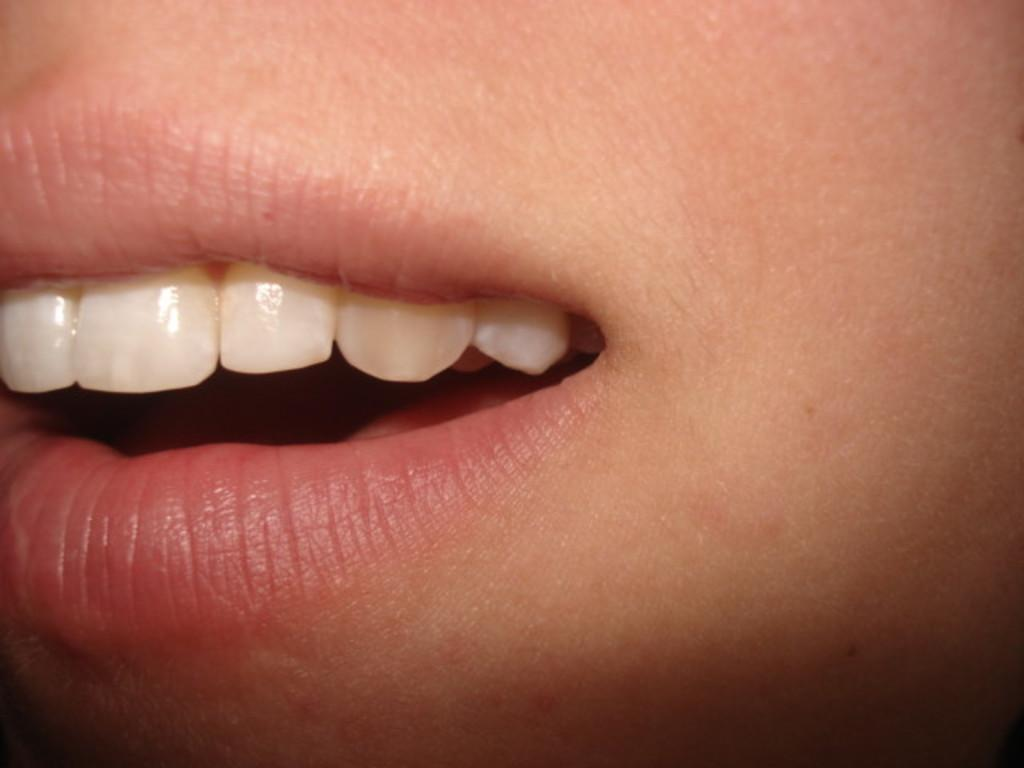What type of body part is visible in the image? There are teeth in the image. What is the color of the teeth? The teeth are white in color. What surrounds the teeth in the image? There are lips above and below the teeth. What is the color of the lips? The lips are pink in color. What type of hair styling tool is being used in the image? There is no hair styling tool present in the image. How does the person in the image express their anger? The image does not show any expression of anger. 